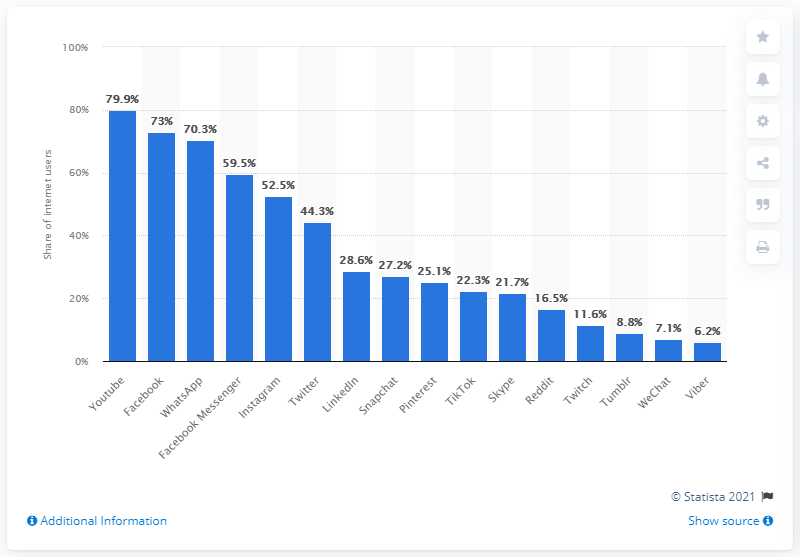Identify some key points in this picture. In the UK, 73% of internet users used Facebook in 2018. 